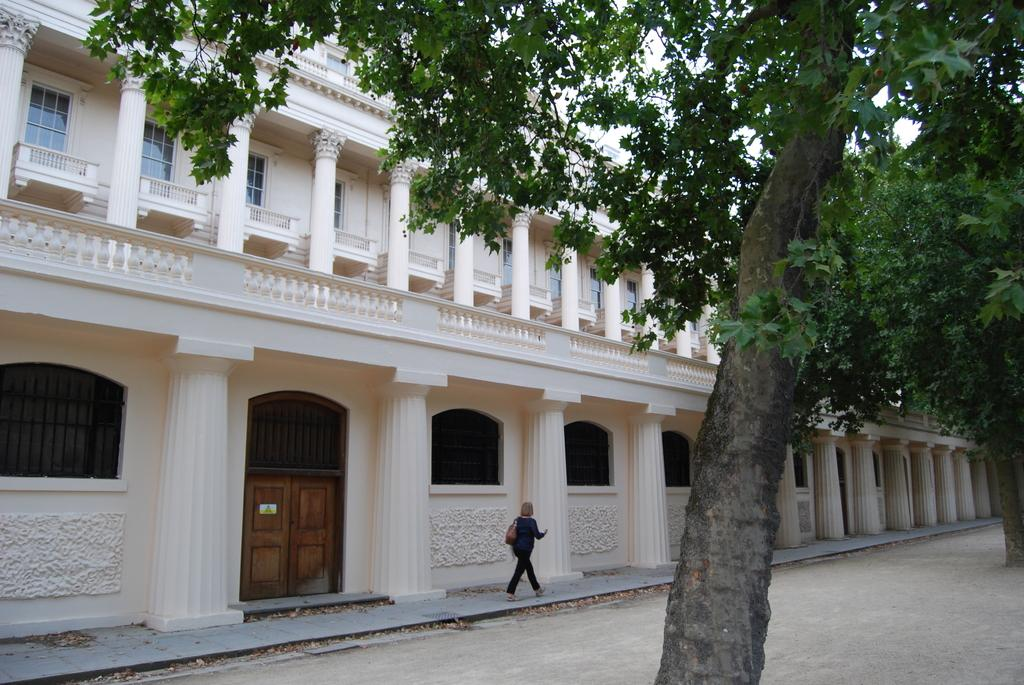What type of structure is visible in the image? There is a building in the image. What natural elements can be seen in the image? There are trees and dried leaves present in the image. What is the woman in the image wearing? The woman is wearing a handbag in the image. What is the woman doing in the image? The woman is walking on a path in the image. What type of terrain is visible in the image? The land is visible in the image. What type of quiver is the woman carrying in the image? There is no quiver present in the image; the woman is carrying a handbag. What is the middle process of the trees in the image? The provided facts do not mention any processes related to the trees, and there is no indication of a middle process. 